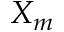<formula> <loc_0><loc_0><loc_500><loc_500>X _ { m }</formula> 